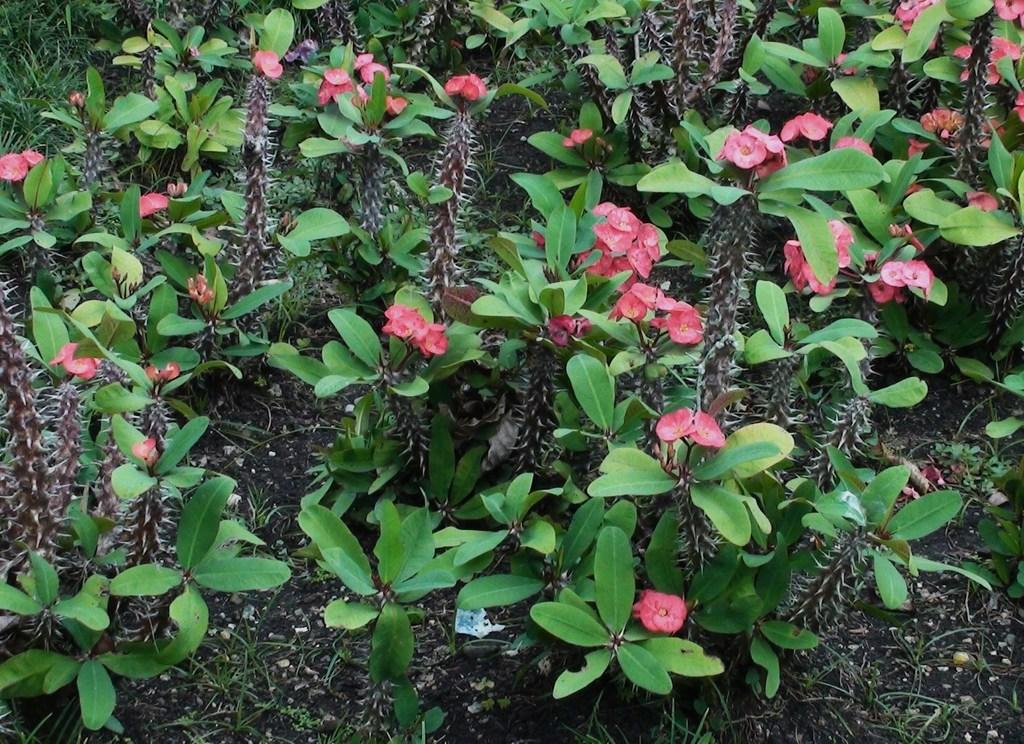What type of living organisms can be seen in the image? Plants can be seen in the image. What specific features do the plants have? The plants have leaves and flowers. What is the name of the plant species in the image? The plants are named as crown-of-thorns. What type of copy machine can be seen in the image? There is no copy machine present in the image; it features plants with leaves and flowers. Is there a watch visible on any of the plants in the image? There is no watch present on the plants in the image. 